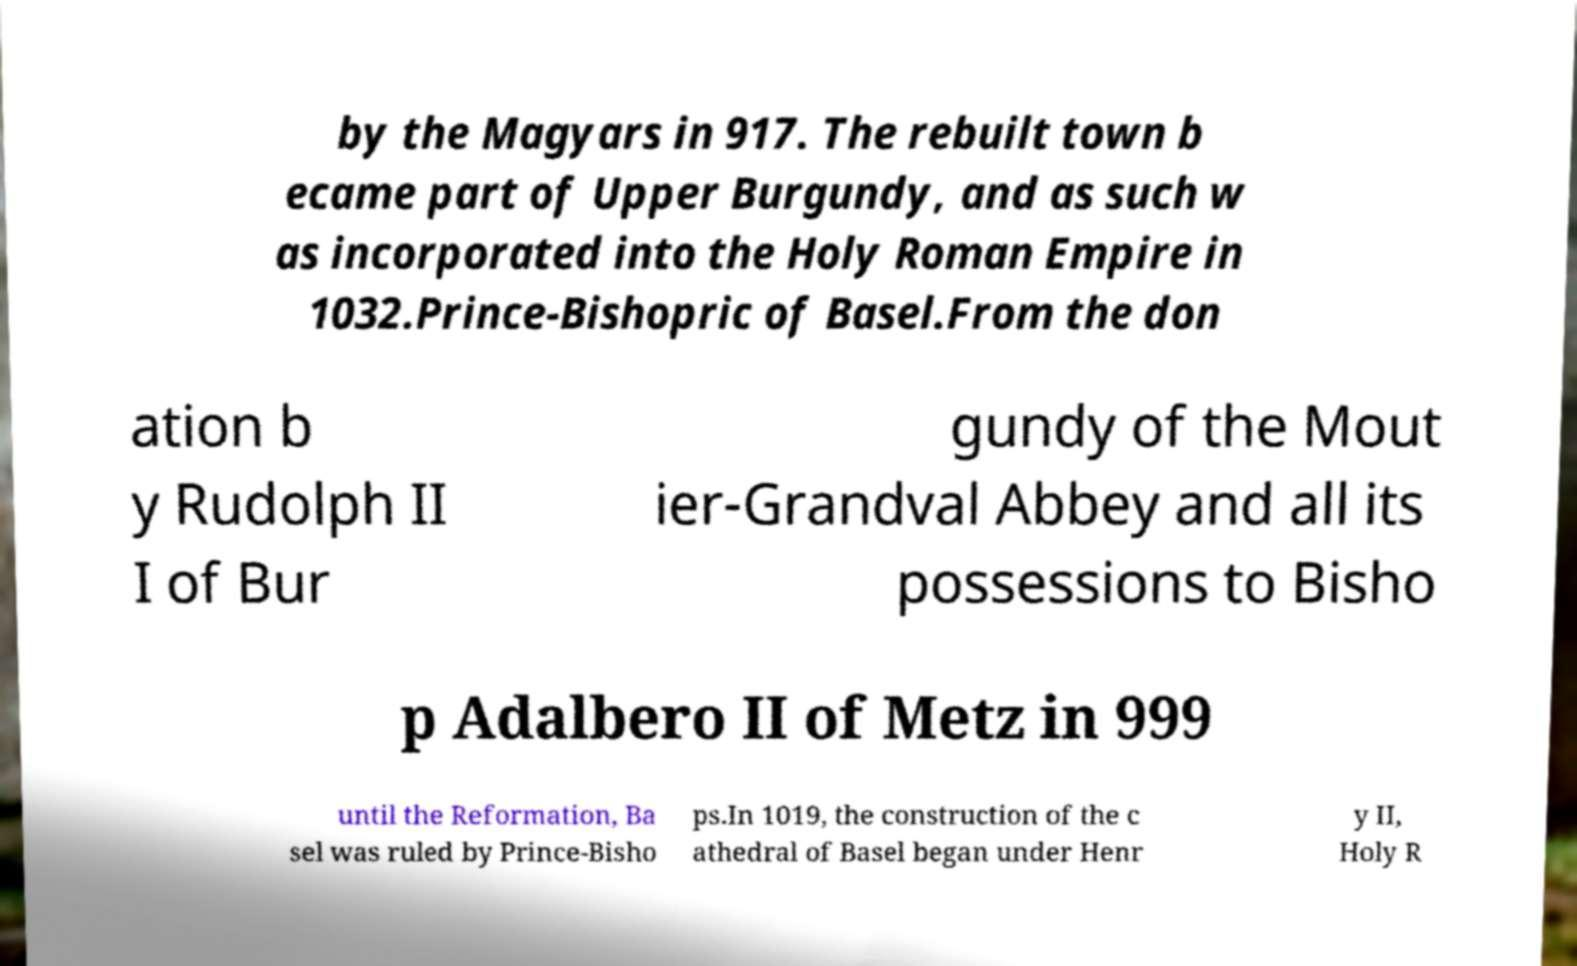For documentation purposes, I need the text within this image transcribed. Could you provide that? by the Magyars in 917. The rebuilt town b ecame part of Upper Burgundy, and as such w as incorporated into the Holy Roman Empire in 1032.Prince-Bishopric of Basel.From the don ation b y Rudolph II I of Bur gundy of the Mout ier-Grandval Abbey and all its possessions to Bisho p Adalbero II of Metz in 999 until the Reformation, Ba sel was ruled by Prince-Bisho ps.In 1019, the construction of the c athedral of Basel began under Henr y II, Holy R 